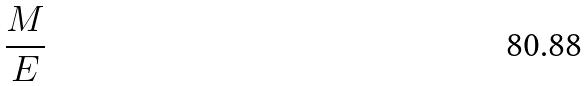Convert formula to latex. <formula><loc_0><loc_0><loc_500><loc_500>\frac { M } { E }</formula> 